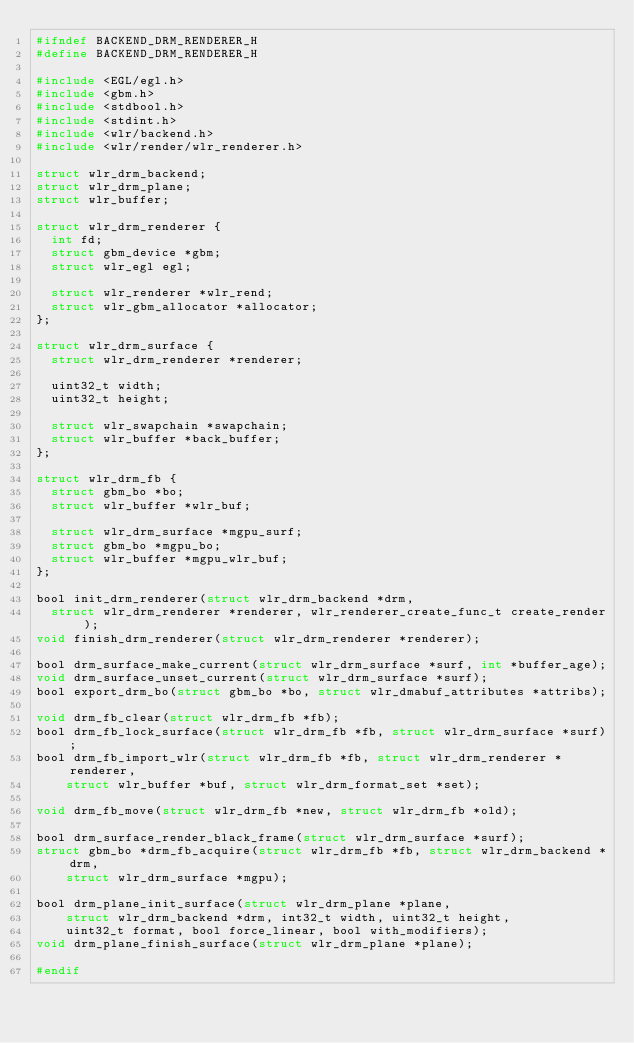Convert code to text. <code><loc_0><loc_0><loc_500><loc_500><_C_>#ifndef BACKEND_DRM_RENDERER_H
#define BACKEND_DRM_RENDERER_H

#include <EGL/egl.h>
#include <gbm.h>
#include <stdbool.h>
#include <stdint.h>
#include <wlr/backend.h>
#include <wlr/render/wlr_renderer.h>

struct wlr_drm_backend;
struct wlr_drm_plane;
struct wlr_buffer;

struct wlr_drm_renderer {
	int fd;
	struct gbm_device *gbm;
	struct wlr_egl egl;

	struct wlr_renderer *wlr_rend;
	struct wlr_gbm_allocator *allocator;
};

struct wlr_drm_surface {
	struct wlr_drm_renderer *renderer;

	uint32_t width;
	uint32_t height;

	struct wlr_swapchain *swapchain;
	struct wlr_buffer *back_buffer;
};

struct wlr_drm_fb {
	struct gbm_bo *bo;
	struct wlr_buffer *wlr_buf;

	struct wlr_drm_surface *mgpu_surf;
	struct gbm_bo *mgpu_bo;
	struct wlr_buffer *mgpu_wlr_buf;
};

bool init_drm_renderer(struct wlr_drm_backend *drm,
	struct wlr_drm_renderer *renderer, wlr_renderer_create_func_t create_render);
void finish_drm_renderer(struct wlr_drm_renderer *renderer);

bool drm_surface_make_current(struct wlr_drm_surface *surf, int *buffer_age);
void drm_surface_unset_current(struct wlr_drm_surface *surf);
bool export_drm_bo(struct gbm_bo *bo, struct wlr_dmabuf_attributes *attribs);

void drm_fb_clear(struct wlr_drm_fb *fb);
bool drm_fb_lock_surface(struct wlr_drm_fb *fb, struct wlr_drm_surface *surf);
bool drm_fb_import_wlr(struct wlr_drm_fb *fb, struct wlr_drm_renderer *renderer,
		struct wlr_buffer *buf, struct wlr_drm_format_set *set);

void drm_fb_move(struct wlr_drm_fb *new, struct wlr_drm_fb *old);

bool drm_surface_render_black_frame(struct wlr_drm_surface *surf);
struct gbm_bo *drm_fb_acquire(struct wlr_drm_fb *fb, struct wlr_drm_backend *drm,
		struct wlr_drm_surface *mgpu);

bool drm_plane_init_surface(struct wlr_drm_plane *plane,
		struct wlr_drm_backend *drm, int32_t width, uint32_t height,
		uint32_t format, bool force_linear, bool with_modifiers);
void drm_plane_finish_surface(struct wlr_drm_plane *plane);

#endif
</code> 